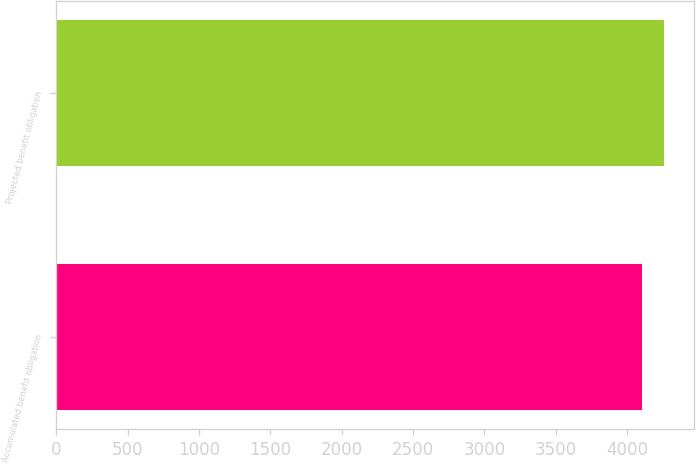Convert chart. <chart><loc_0><loc_0><loc_500><loc_500><bar_chart><fcel>Accumulated benefit obligation<fcel>Projected benefit obligation<nl><fcel>4104<fcel>4257.2<nl></chart> 